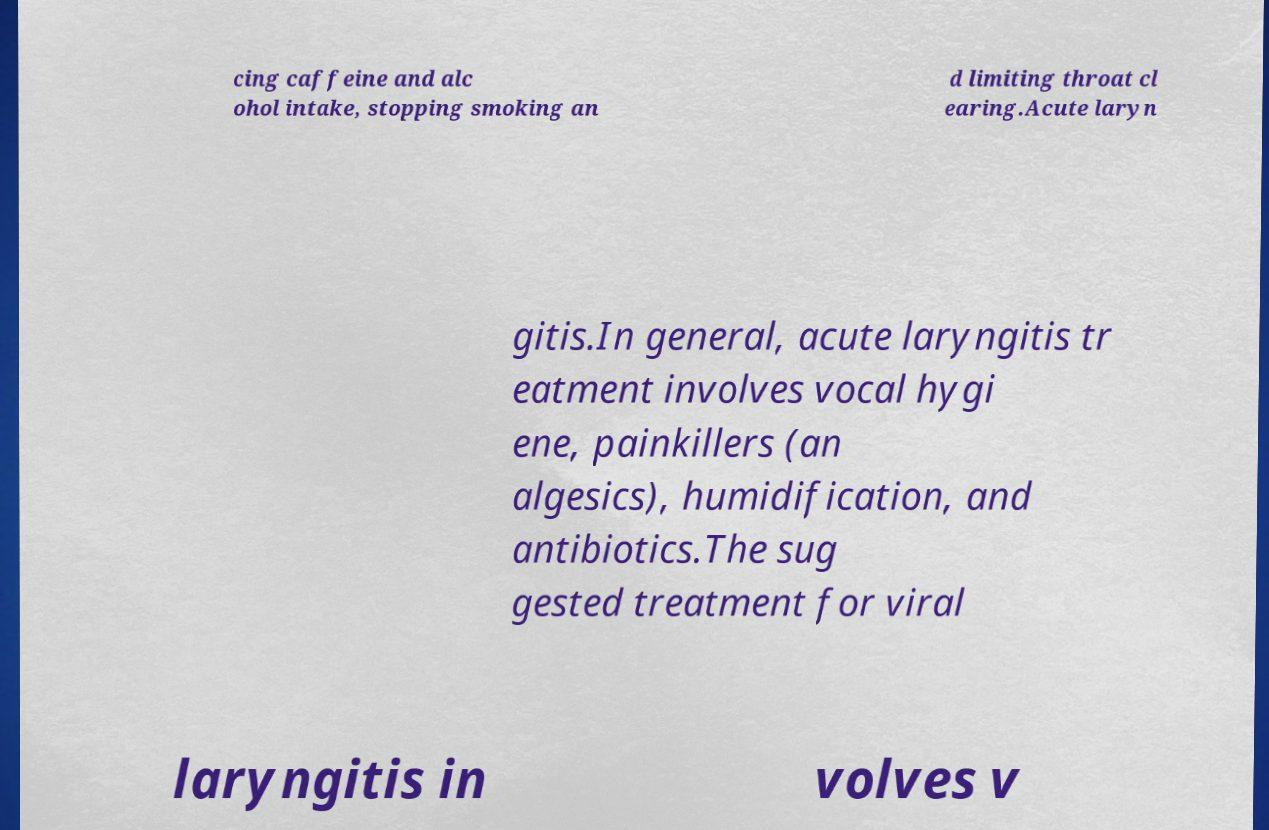Please read and relay the text visible in this image. What does it say? cing caffeine and alc ohol intake, stopping smoking an d limiting throat cl earing.Acute laryn gitis.In general, acute laryngitis tr eatment involves vocal hygi ene, painkillers (an algesics), humidification, and antibiotics.The sug gested treatment for viral laryngitis in volves v 